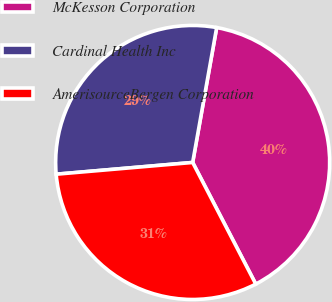<chart> <loc_0><loc_0><loc_500><loc_500><pie_chart><fcel>McKesson Corporation<fcel>Cardinal Health Inc<fcel>AmerisourceBergen Corporation<nl><fcel>39.58%<fcel>29.17%<fcel>31.25%<nl></chart> 